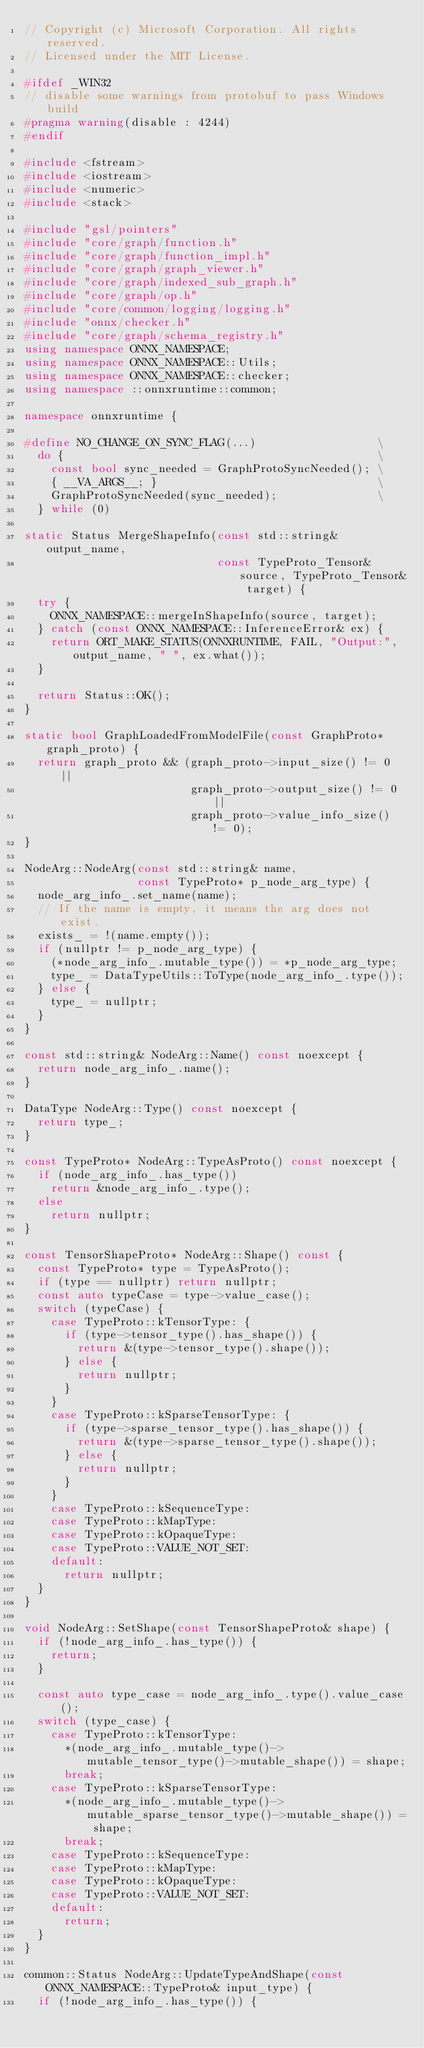<code> <loc_0><loc_0><loc_500><loc_500><_C++_>// Copyright (c) Microsoft Corporation. All rights reserved.
// Licensed under the MIT License.

#ifdef _WIN32
// disable some warnings from protobuf to pass Windows build
#pragma warning(disable : 4244)
#endif

#include <fstream>
#include <iostream>
#include <numeric>
#include <stack>

#include "gsl/pointers"
#include "core/graph/function.h"
#include "core/graph/function_impl.h"
#include "core/graph/graph_viewer.h"
#include "core/graph/indexed_sub_graph.h"
#include "core/graph/op.h"
#include "core/common/logging/logging.h"
#include "onnx/checker.h"
#include "core/graph/schema_registry.h"
using namespace ONNX_NAMESPACE;
using namespace ONNX_NAMESPACE::Utils;
using namespace ONNX_NAMESPACE::checker;
using namespace ::onnxruntime::common;

namespace onnxruntime {

#define NO_CHANGE_ON_SYNC_FLAG(...)                  \
  do {                                               \
    const bool sync_needed = GraphProtoSyncNeeded(); \
    { __VA_ARGS__; }                                 \
    GraphProtoSyncNeeded(sync_needed);               \
  } while (0)

static Status MergeShapeInfo(const std::string& output_name,
                             const TypeProto_Tensor& source, TypeProto_Tensor& target) {
  try {
    ONNX_NAMESPACE::mergeInShapeInfo(source, target);
  } catch (const ONNX_NAMESPACE::InferenceError& ex) {
    return ORT_MAKE_STATUS(ONNXRUNTIME, FAIL, "Output:", output_name, " ", ex.what());
  }

  return Status::OK();
}

static bool GraphLoadedFromModelFile(const GraphProto* graph_proto) {
  return graph_proto && (graph_proto->input_size() != 0 ||
                         graph_proto->output_size() != 0 ||
                         graph_proto->value_info_size() != 0);
}

NodeArg::NodeArg(const std::string& name,
                 const TypeProto* p_node_arg_type) {
  node_arg_info_.set_name(name);
  // If the name is empty, it means the arg does not exist.
  exists_ = !(name.empty());
  if (nullptr != p_node_arg_type) {
    (*node_arg_info_.mutable_type()) = *p_node_arg_type;
    type_ = DataTypeUtils::ToType(node_arg_info_.type());
  } else {
    type_ = nullptr;
  }
}

const std::string& NodeArg::Name() const noexcept {
  return node_arg_info_.name();
}

DataType NodeArg::Type() const noexcept {
  return type_;
}

const TypeProto* NodeArg::TypeAsProto() const noexcept {
  if (node_arg_info_.has_type())
    return &node_arg_info_.type();
  else
    return nullptr;
}

const TensorShapeProto* NodeArg::Shape() const {
  const TypeProto* type = TypeAsProto();
  if (type == nullptr) return nullptr;
  const auto typeCase = type->value_case();
  switch (typeCase) {
    case TypeProto::kTensorType: {
      if (type->tensor_type().has_shape()) {
        return &(type->tensor_type().shape());
      } else {
        return nullptr;
      }
    }
    case TypeProto::kSparseTensorType: {
      if (type->sparse_tensor_type().has_shape()) {
        return &(type->sparse_tensor_type().shape());
      } else {
        return nullptr;
      }
    }
    case TypeProto::kSequenceType:
    case TypeProto::kMapType:
    case TypeProto::kOpaqueType:
    case TypeProto::VALUE_NOT_SET:
    default:
      return nullptr;
  }
}

void NodeArg::SetShape(const TensorShapeProto& shape) {
  if (!node_arg_info_.has_type()) {
    return;
  }

  const auto type_case = node_arg_info_.type().value_case();
  switch (type_case) {
    case TypeProto::kTensorType:
      *(node_arg_info_.mutable_type()->mutable_tensor_type()->mutable_shape()) = shape;
      break;
    case TypeProto::kSparseTensorType:
      *(node_arg_info_.mutable_type()->mutable_sparse_tensor_type()->mutable_shape()) = shape;
      break;
    case TypeProto::kSequenceType:
    case TypeProto::kMapType:
    case TypeProto::kOpaqueType:
    case TypeProto::VALUE_NOT_SET:
    default:
      return;
  }
}

common::Status NodeArg::UpdateTypeAndShape(const ONNX_NAMESPACE::TypeProto& input_type) {
  if (!node_arg_info_.has_type()) {</code> 